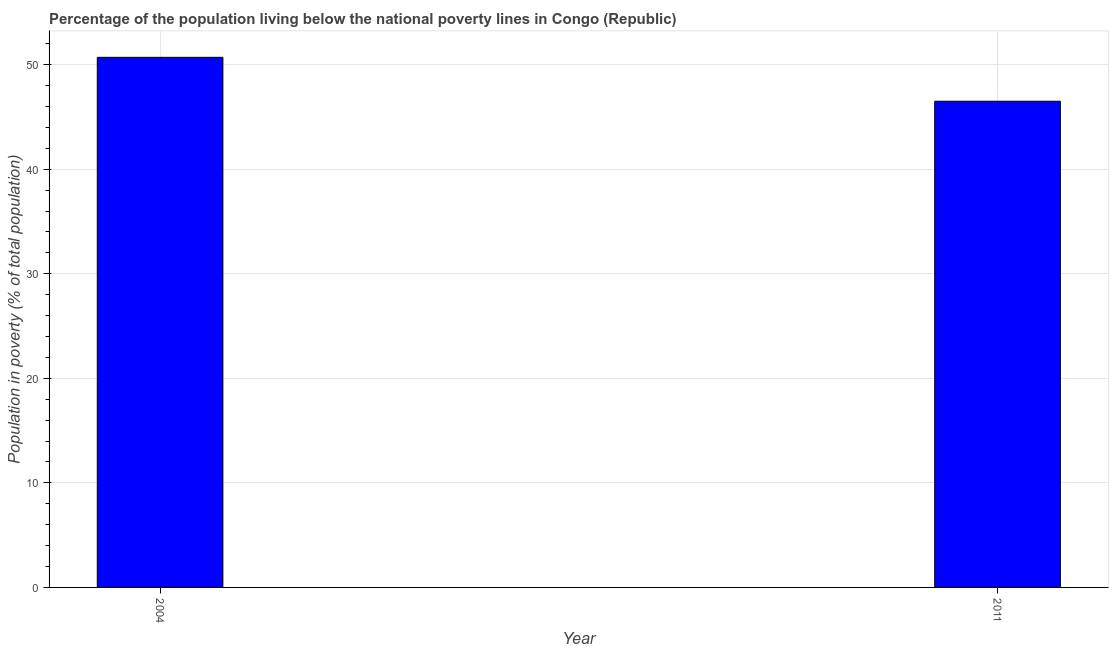Does the graph contain any zero values?
Your answer should be very brief. No. Does the graph contain grids?
Your response must be concise. Yes. What is the title of the graph?
Provide a succinct answer. Percentage of the population living below the national poverty lines in Congo (Republic). What is the label or title of the X-axis?
Offer a very short reply. Year. What is the label or title of the Y-axis?
Ensure brevity in your answer.  Population in poverty (% of total population). What is the percentage of population living below poverty line in 2004?
Provide a succinct answer. 50.7. Across all years, what is the maximum percentage of population living below poverty line?
Provide a succinct answer. 50.7. Across all years, what is the minimum percentage of population living below poverty line?
Keep it short and to the point. 46.5. In which year was the percentage of population living below poverty line maximum?
Provide a short and direct response. 2004. In which year was the percentage of population living below poverty line minimum?
Your answer should be very brief. 2011. What is the sum of the percentage of population living below poverty line?
Give a very brief answer. 97.2. What is the average percentage of population living below poverty line per year?
Ensure brevity in your answer.  48.6. What is the median percentage of population living below poverty line?
Keep it short and to the point. 48.6. Do a majority of the years between 2011 and 2004 (inclusive) have percentage of population living below poverty line greater than 34 %?
Make the answer very short. No. What is the ratio of the percentage of population living below poverty line in 2004 to that in 2011?
Your answer should be compact. 1.09. How many bars are there?
Keep it short and to the point. 2. What is the Population in poverty (% of total population) of 2004?
Your answer should be very brief. 50.7. What is the Population in poverty (% of total population) of 2011?
Your response must be concise. 46.5. What is the difference between the Population in poverty (% of total population) in 2004 and 2011?
Provide a short and direct response. 4.2. What is the ratio of the Population in poverty (% of total population) in 2004 to that in 2011?
Give a very brief answer. 1.09. 